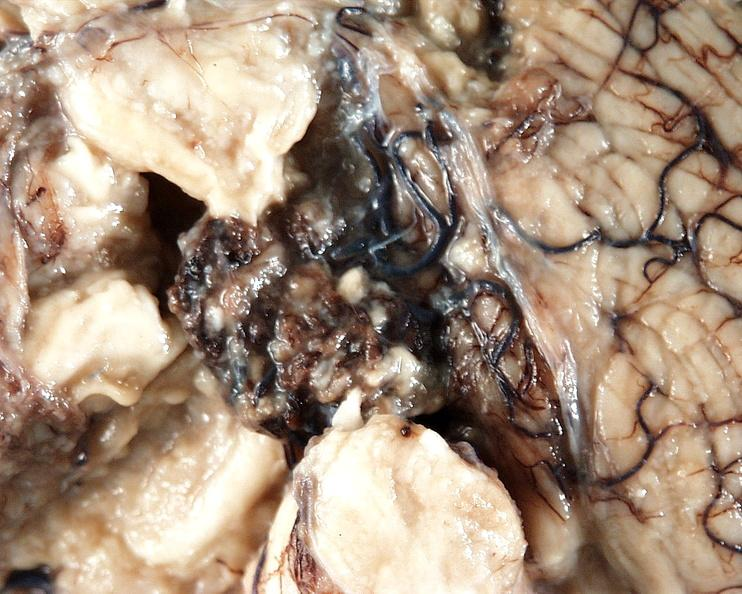does this image show brain, cryptococcal meningitis?
Answer the question using a single word or phrase. Yes 